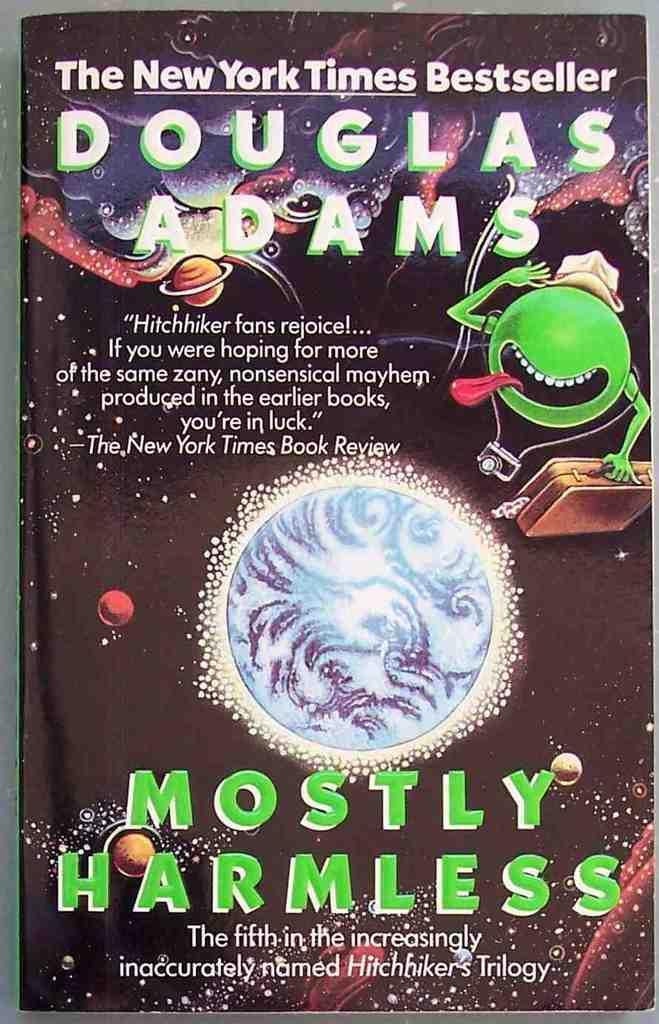Provide a one-sentence caption for the provided image. The fifth book in Douglas Adams' Hitchhiker's series. 